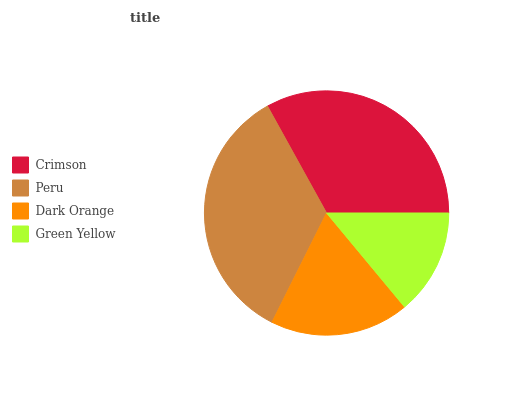Is Green Yellow the minimum?
Answer yes or no. Yes. Is Peru the maximum?
Answer yes or no. Yes. Is Dark Orange the minimum?
Answer yes or no. No. Is Dark Orange the maximum?
Answer yes or no. No. Is Peru greater than Dark Orange?
Answer yes or no. Yes. Is Dark Orange less than Peru?
Answer yes or no. Yes. Is Dark Orange greater than Peru?
Answer yes or no. No. Is Peru less than Dark Orange?
Answer yes or no. No. Is Crimson the high median?
Answer yes or no. Yes. Is Dark Orange the low median?
Answer yes or no. Yes. Is Dark Orange the high median?
Answer yes or no. No. Is Peru the low median?
Answer yes or no. No. 